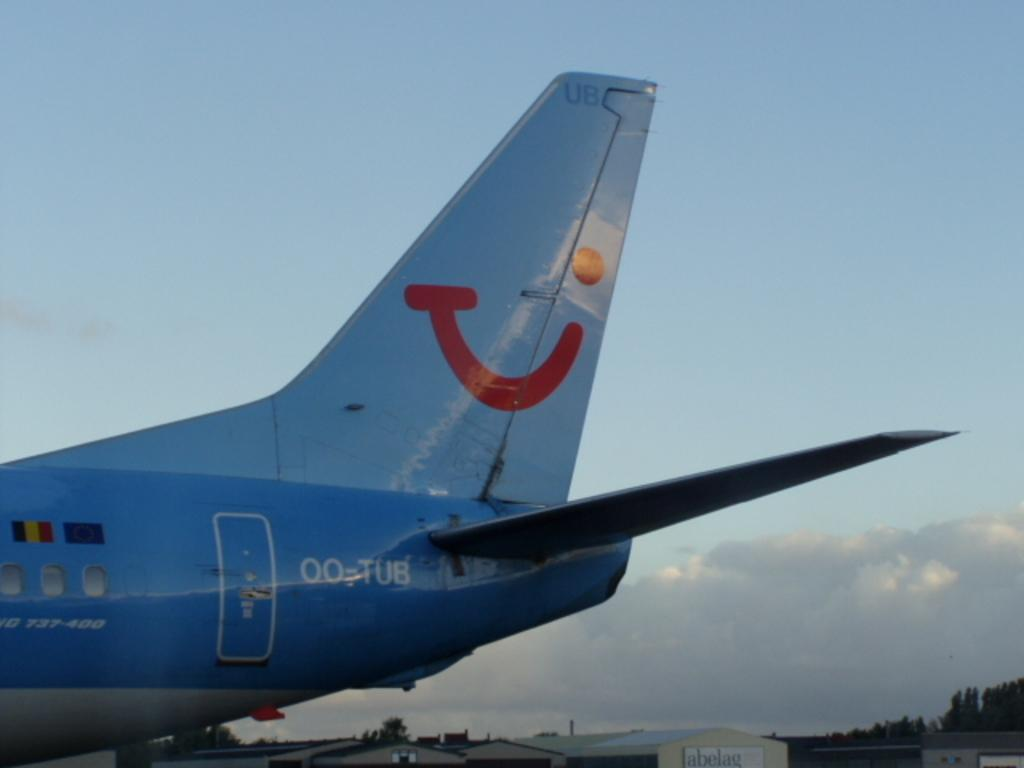What is the main subject of the picture? The main subject of the picture is an airplane. Do the airplane have any specific features? Yes, the airplane has windows, a rudder, and a wing. What else can be seen in the image besides the airplane? There are buildings, trees, and a clear sky visible in the image. What type of disgust can be seen on the airplane's face in the image? There is no face on the airplane in the image, as it is an inanimate object and cannot display emotions or disgust. 